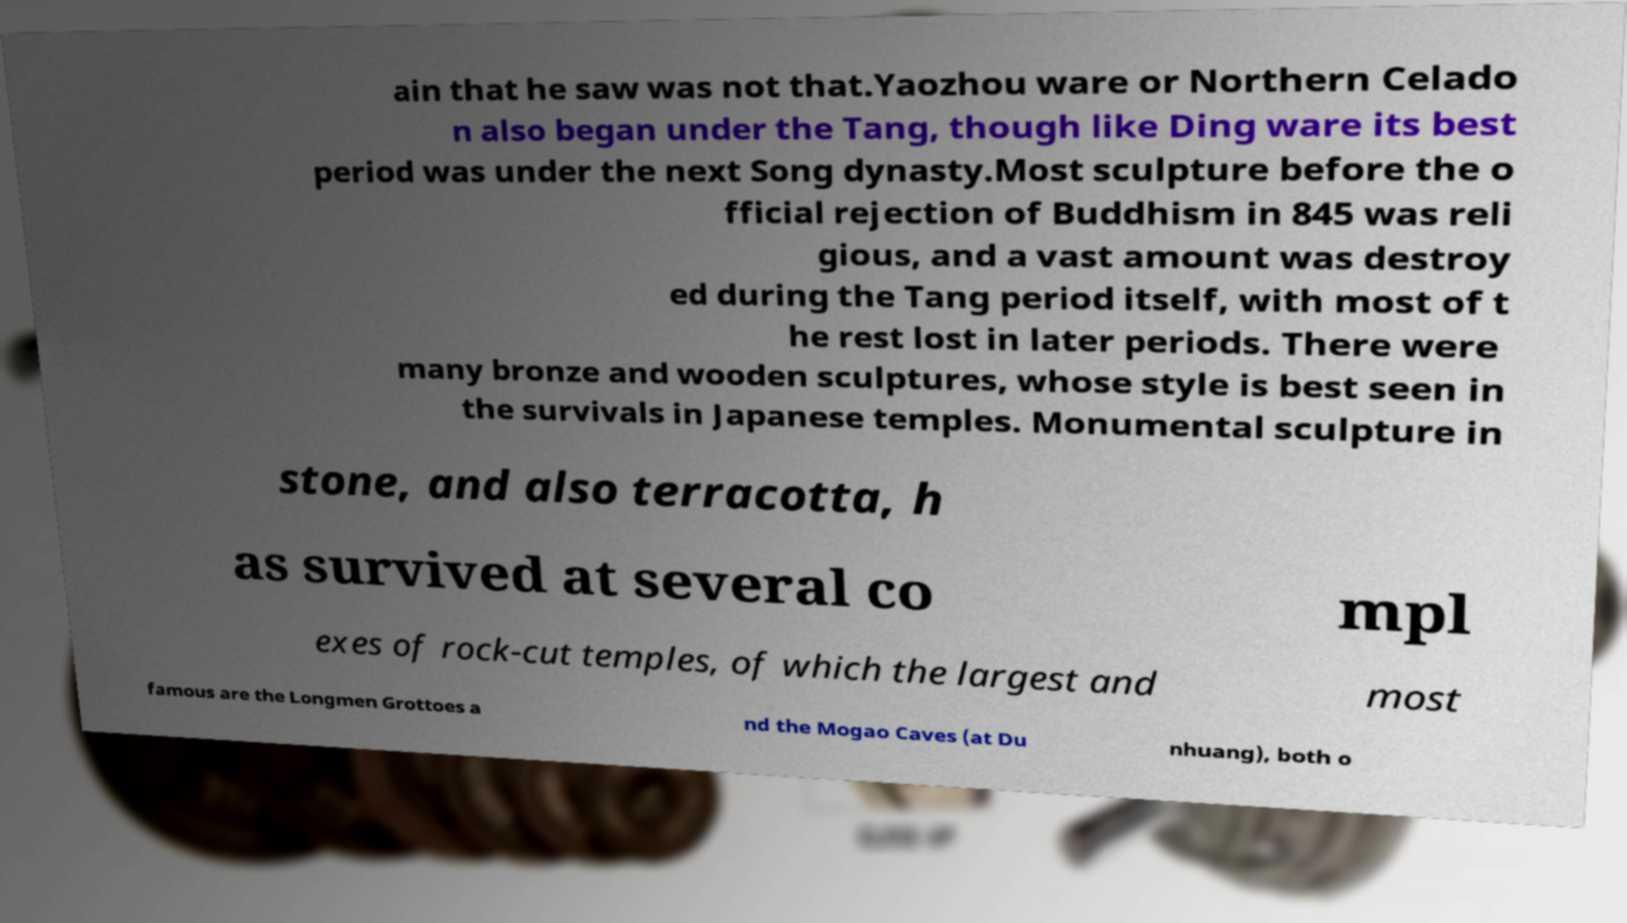I need the written content from this picture converted into text. Can you do that? ain that he saw was not that.Yaozhou ware or Northern Celado n also began under the Tang, though like Ding ware its best period was under the next Song dynasty.Most sculpture before the o fficial rejection of Buddhism in 845 was reli gious, and a vast amount was destroy ed during the Tang period itself, with most of t he rest lost in later periods. There were many bronze and wooden sculptures, whose style is best seen in the survivals in Japanese temples. Monumental sculpture in stone, and also terracotta, h as survived at several co mpl exes of rock-cut temples, of which the largest and most famous are the Longmen Grottoes a nd the Mogao Caves (at Du nhuang), both o 